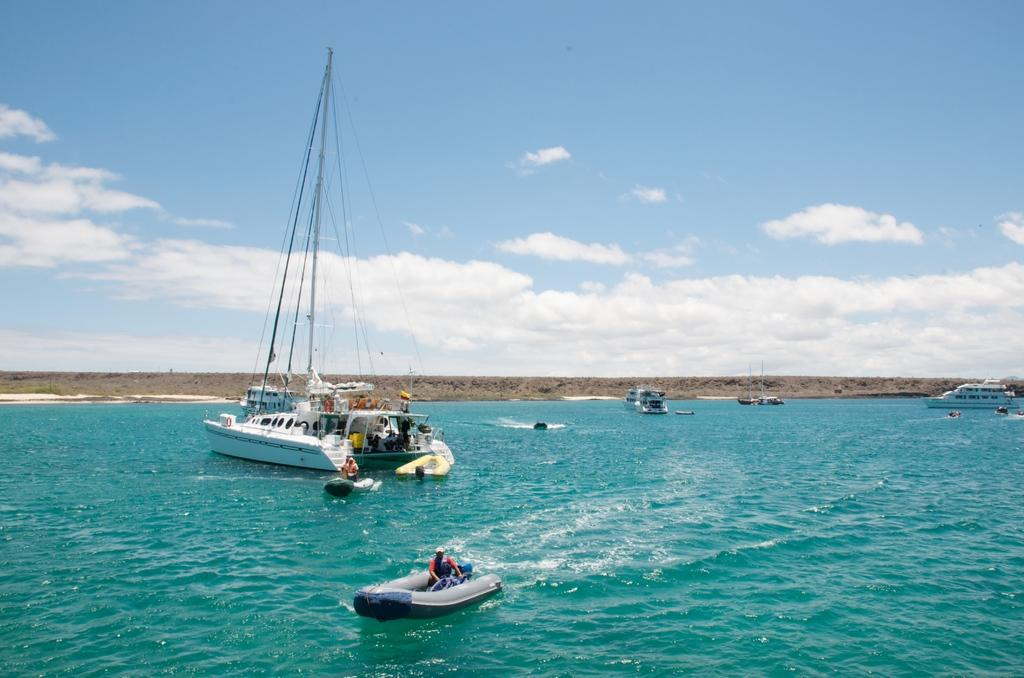What type of body of water is present in the image? There is an ocean in the image. What is floating on the water in the image? There are boats on the water in the image. Can you describe the boat with a person in the image? There is a boat with a person at the bottom of the image. What can be seen in the distance in the image? There is land visible in the background of the image. What else is visible in the background of the image? The sky is visible in the background of the image, and there are clouds in the sky. Where is the hydrant located in the image? There is no hydrant present in the image. What type of gate can be seen in the image? There is no gate present in the image. 